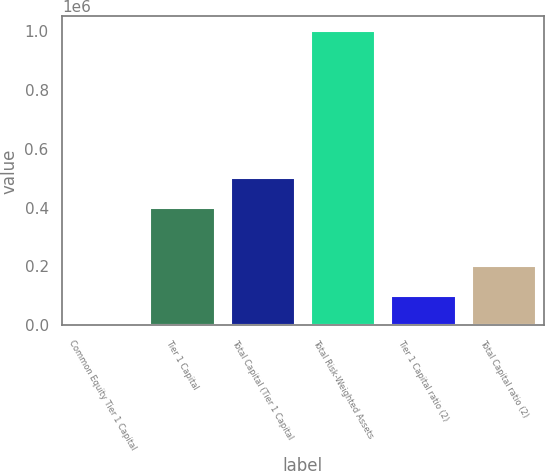<chart> <loc_0><loc_0><loc_500><loc_500><bar_chart><fcel>Common Equity Tier 1 Capital<fcel>Tier 1 Capital<fcel>Total Capital (Tier 1 Capital<fcel>Total Risk-Weighted Assets<fcel>Tier 1 Capital ratio (2)<fcel>Total Capital ratio (2)<nl><fcel>12.62<fcel>400341<fcel>500423<fcel>1.00083e+06<fcel>100095<fcel>200177<nl></chart> 